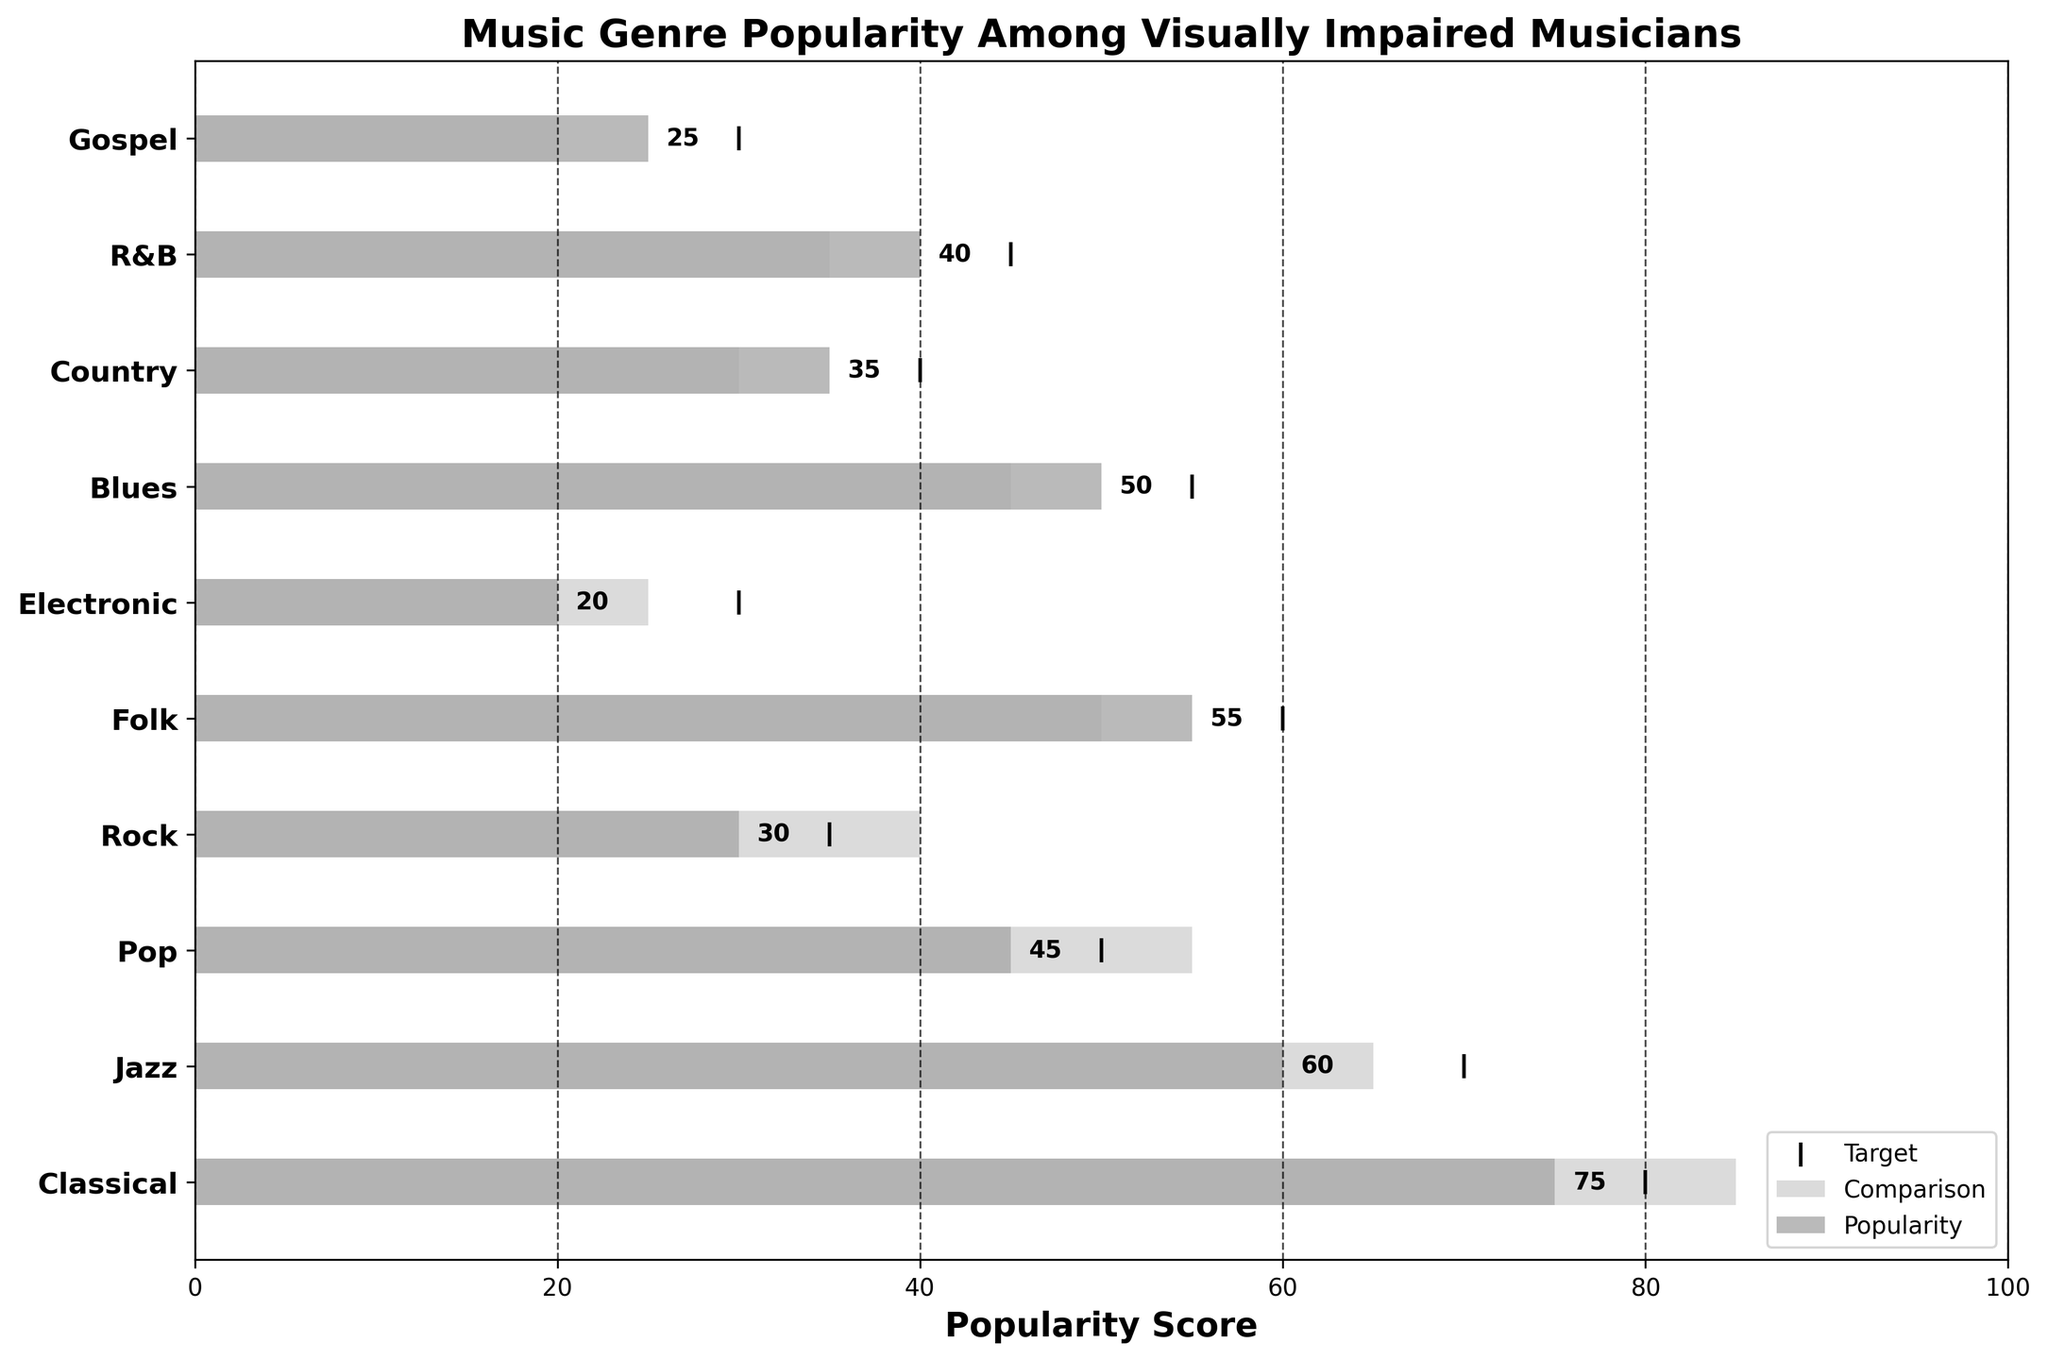What is the title of the figure? The title is usually located at the top of the figure. By reading the title, you can easily understand the main subject of the chart.
Answer: Music Genre Popularity Among Visually Impaired Musicians Which genre has the highest popularity score? You find the highest value in the "Popularity" section of the figure and identify the corresponding genre.
Answer: Classical What is the popularity score for Jazz? Locate the Jazz genre in the list and read its corresponding popularity score value.
Answer: 60 Does any genre have a higher comparison score than its target score? Check each genre to see if the "Comparison" value is greater than the "Target" value.
Answer: No How many genres have a popularity score of 50 or higher? Count the number of genres in the "Popularity" section with scores equal to or above 50.
Answer: Four Which genre has a lower popularity score compared to its comparison score, but meets its target score? Identify genres where the popularity score is less than the comparison score but equal to the target score: For Blues: 50 (Pop) vs 55 (Target); R&B: 40 vs 45, etc.
Answer: None Which genre's popularity score is exactly in the middle of the range 0-100? Find the genre whose popularity score is closest to 50.
Answer: Pop In how many genres is the popularity score less than both the comparison and target scores? Count the genres where the popularity score is less than both comparison and target values.
Answer: Three 